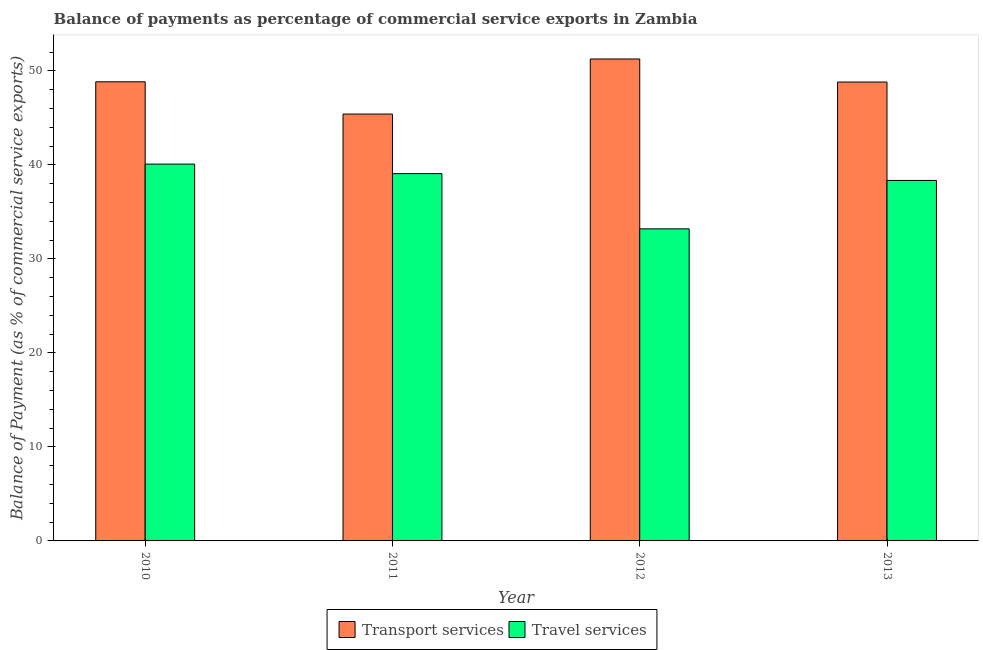How many different coloured bars are there?
Your response must be concise. 2. Are the number of bars per tick equal to the number of legend labels?
Your answer should be very brief. Yes. Are the number of bars on each tick of the X-axis equal?
Your answer should be compact. Yes. How many bars are there on the 2nd tick from the left?
Offer a terse response. 2. What is the label of the 3rd group of bars from the left?
Your answer should be very brief. 2012. What is the balance of payments of transport services in 2012?
Keep it short and to the point. 51.27. Across all years, what is the maximum balance of payments of travel services?
Give a very brief answer. 40.09. Across all years, what is the minimum balance of payments of transport services?
Give a very brief answer. 45.41. In which year was the balance of payments of travel services maximum?
Ensure brevity in your answer.  2010. In which year was the balance of payments of transport services minimum?
Ensure brevity in your answer.  2011. What is the total balance of payments of travel services in the graph?
Make the answer very short. 150.72. What is the difference between the balance of payments of travel services in 2011 and that in 2013?
Provide a short and direct response. 0.72. What is the difference between the balance of payments of travel services in 2012 and the balance of payments of transport services in 2011?
Your answer should be compact. -5.87. What is the average balance of payments of transport services per year?
Make the answer very short. 48.59. In the year 2010, what is the difference between the balance of payments of transport services and balance of payments of travel services?
Your answer should be compact. 0. What is the ratio of the balance of payments of transport services in 2011 to that in 2013?
Provide a succinct answer. 0.93. Is the balance of payments of transport services in 2012 less than that in 2013?
Your answer should be very brief. No. What is the difference between the highest and the second highest balance of payments of travel services?
Offer a terse response. 1.02. What is the difference between the highest and the lowest balance of payments of travel services?
Provide a succinct answer. 6.89. In how many years, is the balance of payments of transport services greater than the average balance of payments of transport services taken over all years?
Ensure brevity in your answer.  3. Is the sum of the balance of payments of transport services in 2010 and 2011 greater than the maximum balance of payments of travel services across all years?
Your response must be concise. Yes. What does the 2nd bar from the left in 2013 represents?
Provide a succinct answer. Travel services. What does the 2nd bar from the right in 2011 represents?
Offer a terse response. Transport services. How many bars are there?
Your answer should be compact. 8. How many years are there in the graph?
Provide a short and direct response. 4. What is the difference between two consecutive major ticks on the Y-axis?
Your answer should be compact. 10. Are the values on the major ticks of Y-axis written in scientific E-notation?
Ensure brevity in your answer.  No. Does the graph contain grids?
Provide a succinct answer. No. Where does the legend appear in the graph?
Your answer should be very brief. Bottom center. How many legend labels are there?
Keep it short and to the point. 2. What is the title of the graph?
Offer a very short reply. Balance of payments as percentage of commercial service exports in Zambia. What is the label or title of the Y-axis?
Keep it short and to the point. Balance of Payment (as % of commercial service exports). What is the Balance of Payment (as % of commercial service exports) in Transport services in 2010?
Ensure brevity in your answer.  48.85. What is the Balance of Payment (as % of commercial service exports) of Travel services in 2010?
Keep it short and to the point. 40.09. What is the Balance of Payment (as % of commercial service exports) of Transport services in 2011?
Provide a short and direct response. 45.41. What is the Balance of Payment (as % of commercial service exports) in Travel services in 2011?
Offer a terse response. 39.07. What is the Balance of Payment (as % of commercial service exports) in Transport services in 2012?
Provide a succinct answer. 51.27. What is the Balance of Payment (as % of commercial service exports) in Travel services in 2012?
Ensure brevity in your answer.  33.2. What is the Balance of Payment (as % of commercial service exports) in Transport services in 2013?
Provide a short and direct response. 48.82. What is the Balance of Payment (as % of commercial service exports) of Travel services in 2013?
Offer a terse response. 38.35. Across all years, what is the maximum Balance of Payment (as % of commercial service exports) of Transport services?
Make the answer very short. 51.27. Across all years, what is the maximum Balance of Payment (as % of commercial service exports) of Travel services?
Provide a succinct answer. 40.09. Across all years, what is the minimum Balance of Payment (as % of commercial service exports) of Transport services?
Make the answer very short. 45.41. Across all years, what is the minimum Balance of Payment (as % of commercial service exports) in Travel services?
Keep it short and to the point. 33.2. What is the total Balance of Payment (as % of commercial service exports) in Transport services in the graph?
Provide a short and direct response. 194.36. What is the total Balance of Payment (as % of commercial service exports) in Travel services in the graph?
Keep it short and to the point. 150.72. What is the difference between the Balance of Payment (as % of commercial service exports) in Transport services in 2010 and that in 2011?
Ensure brevity in your answer.  3.43. What is the difference between the Balance of Payment (as % of commercial service exports) of Travel services in 2010 and that in 2011?
Your response must be concise. 1.02. What is the difference between the Balance of Payment (as % of commercial service exports) in Transport services in 2010 and that in 2012?
Provide a succinct answer. -2.43. What is the difference between the Balance of Payment (as % of commercial service exports) of Travel services in 2010 and that in 2012?
Give a very brief answer. 6.89. What is the difference between the Balance of Payment (as % of commercial service exports) of Transport services in 2010 and that in 2013?
Keep it short and to the point. 0.03. What is the difference between the Balance of Payment (as % of commercial service exports) of Travel services in 2010 and that in 2013?
Offer a terse response. 1.74. What is the difference between the Balance of Payment (as % of commercial service exports) of Transport services in 2011 and that in 2012?
Keep it short and to the point. -5.86. What is the difference between the Balance of Payment (as % of commercial service exports) in Travel services in 2011 and that in 2012?
Your answer should be very brief. 5.87. What is the difference between the Balance of Payment (as % of commercial service exports) in Transport services in 2011 and that in 2013?
Keep it short and to the point. -3.41. What is the difference between the Balance of Payment (as % of commercial service exports) in Travel services in 2011 and that in 2013?
Your response must be concise. 0.72. What is the difference between the Balance of Payment (as % of commercial service exports) in Transport services in 2012 and that in 2013?
Offer a very short reply. 2.45. What is the difference between the Balance of Payment (as % of commercial service exports) in Travel services in 2012 and that in 2013?
Your answer should be compact. -5.15. What is the difference between the Balance of Payment (as % of commercial service exports) in Transport services in 2010 and the Balance of Payment (as % of commercial service exports) in Travel services in 2011?
Offer a terse response. 9.77. What is the difference between the Balance of Payment (as % of commercial service exports) in Transport services in 2010 and the Balance of Payment (as % of commercial service exports) in Travel services in 2012?
Keep it short and to the point. 15.64. What is the difference between the Balance of Payment (as % of commercial service exports) in Transport services in 2010 and the Balance of Payment (as % of commercial service exports) in Travel services in 2013?
Provide a succinct answer. 10.5. What is the difference between the Balance of Payment (as % of commercial service exports) of Transport services in 2011 and the Balance of Payment (as % of commercial service exports) of Travel services in 2012?
Keep it short and to the point. 12.21. What is the difference between the Balance of Payment (as % of commercial service exports) in Transport services in 2011 and the Balance of Payment (as % of commercial service exports) in Travel services in 2013?
Provide a short and direct response. 7.06. What is the difference between the Balance of Payment (as % of commercial service exports) of Transport services in 2012 and the Balance of Payment (as % of commercial service exports) of Travel services in 2013?
Provide a succinct answer. 12.92. What is the average Balance of Payment (as % of commercial service exports) of Transport services per year?
Give a very brief answer. 48.59. What is the average Balance of Payment (as % of commercial service exports) in Travel services per year?
Ensure brevity in your answer.  37.68. In the year 2010, what is the difference between the Balance of Payment (as % of commercial service exports) in Transport services and Balance of Payment (as % of commercial service exports) in Travel services?
Offer a terse response. 8.76. In the year 2011, what is the difference between the Balance of Payment (as % of commercial service exports) in Transport services and Balance of Payment (as % of commercial service exports) in Travel services?
Provide a short and direct response. 6.34. In the year 2012, what is the difference between the Balance of Payment (as % of commercial service exports) of Transport services and Balance of Payment (as % of commercial service exports) of Travel services?
Offer a terse response. 18.07. In the year 2013, what is the difference between the Balance of Payment (as % of commercial service exports) of Transport services and Balance of Payment (as % of commercial service exports) of Travel services?
Your response must be concise. 10.47. What is the ratio of the Balance of Payment (as % of commercial service exports) of Transport services in 2010 to that in 2011?
Ensure brevity in your answer.  1.08. What is the ratio of the Balance of Payment (as % of commercial service exports) of Transport services in 2010 to that in 2012?
Give a very brief answer. 0.95. What is the ratio of the Balance of Payment (as % of commercial service exports) in Travel services in 2010 to that in 2012?
Provide a succinct answer. 1.21. What is the ratio of the Balance of Payment (as % of commercial service exports) of Travel services in 2010 to that in 2013?
Provide a succinct answer. 1.05. What is the ratio of the Balance of Payment (as % of commercial service exports) in Transport services in 2011 to that in 2012?
Ensure brevity in your answer.  0.89. What is the ratio of the Balance of Payment (as % of commercial service exports) of Travel services in 2011 to that in 2012?
Keep it short and to the point. 1.18. What is the ratio of the Balance of Payment (as % of commercial service exports) of Transport services in 2011 to that in 2013?
Keep it short and to the point. 0.93. What is the ratio of the Balance of Payment (as % of commercial service exports) in Travel services in 2011 to that in 2013?
Your answer should be compact. 1.02. What is the ratio of the Balance of Payment (as % of commercial service exports) of Transport services in 2012 to that in 2013?
Provide a succinct answer. 1.05. What is the ratio of the Balance of Payment (as % of commercial service exports) of Travel services in 2012 to that in 2013?
Offer a very short reply. 0.87. What is the difference between the highest and the second highest Balance of Payment (as % of commercial service exports) in Transport services?
Your response must be concise. 2.43. What is the difference between the highest and the second highest Balance of Payment (as % of commercial service exports) of Travel services?
Provide a short and direct response. 1.02. What is the difference between the highest and the lowest Balance of Payment (as % of commercial service exports) of Transport services?
Provide a short and direct response. 5.86. What is the difference between the highest and the lowest Balance of Payment (as % of commercial service exports) in Travel services?
Provide a short and direct response. 6.89. 